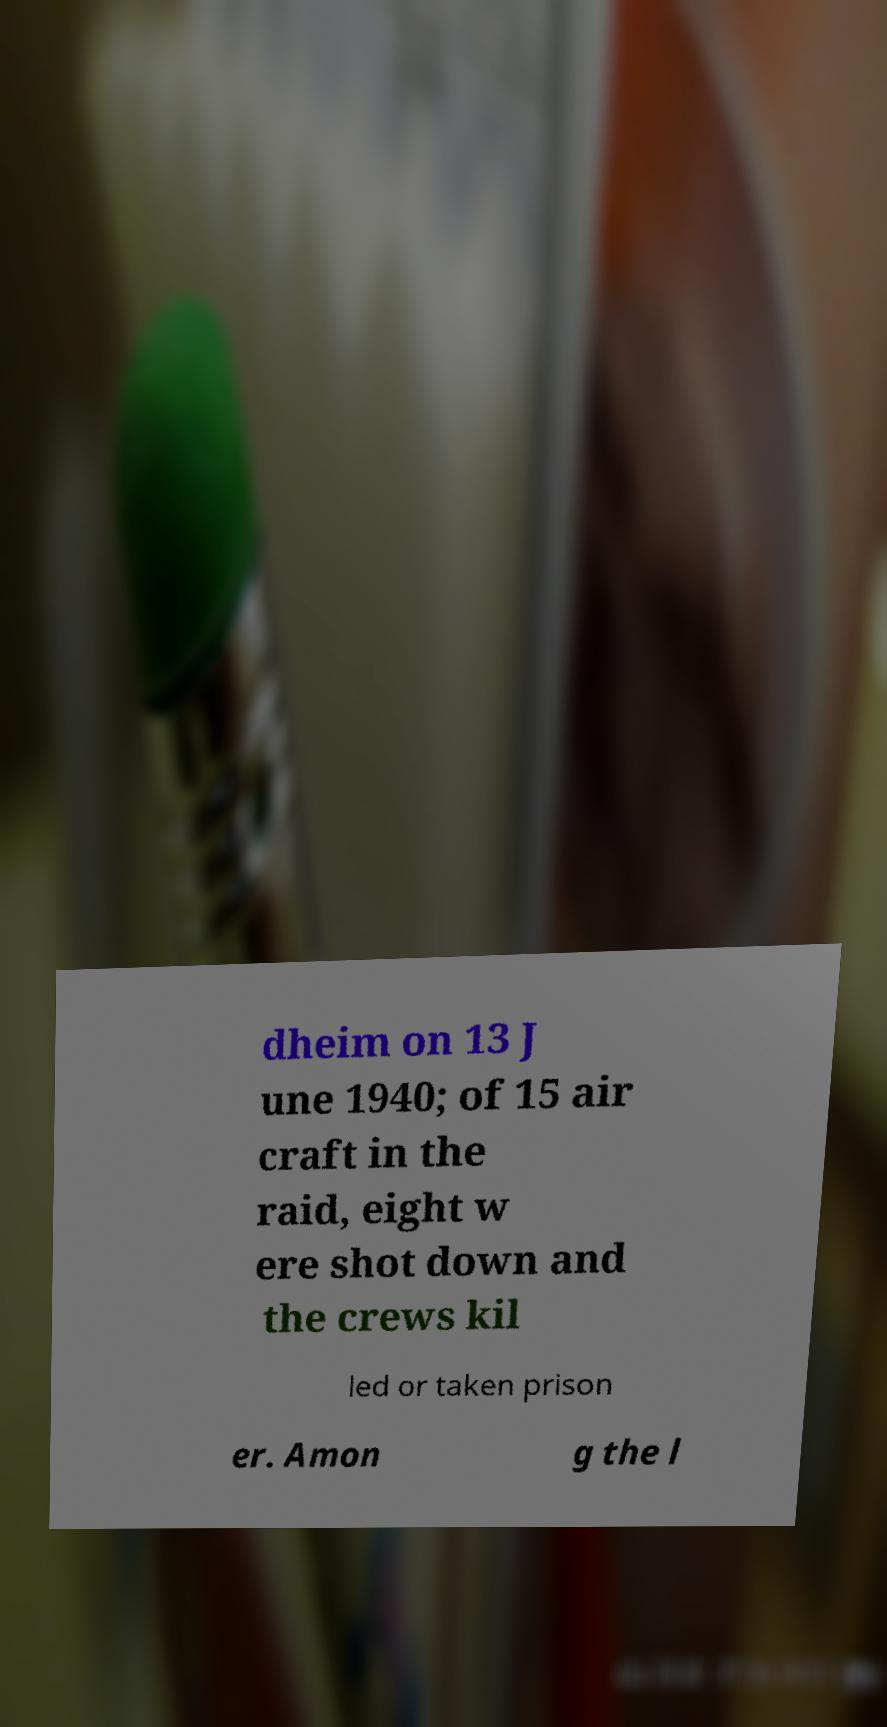Could you assist in decoding the text presented in this image and type it out clearly? dheim on 13 J une 1940; of 15 air craft in the raid, eight w ere shot down and the crews kil led or taken prison er. Amon g the l 